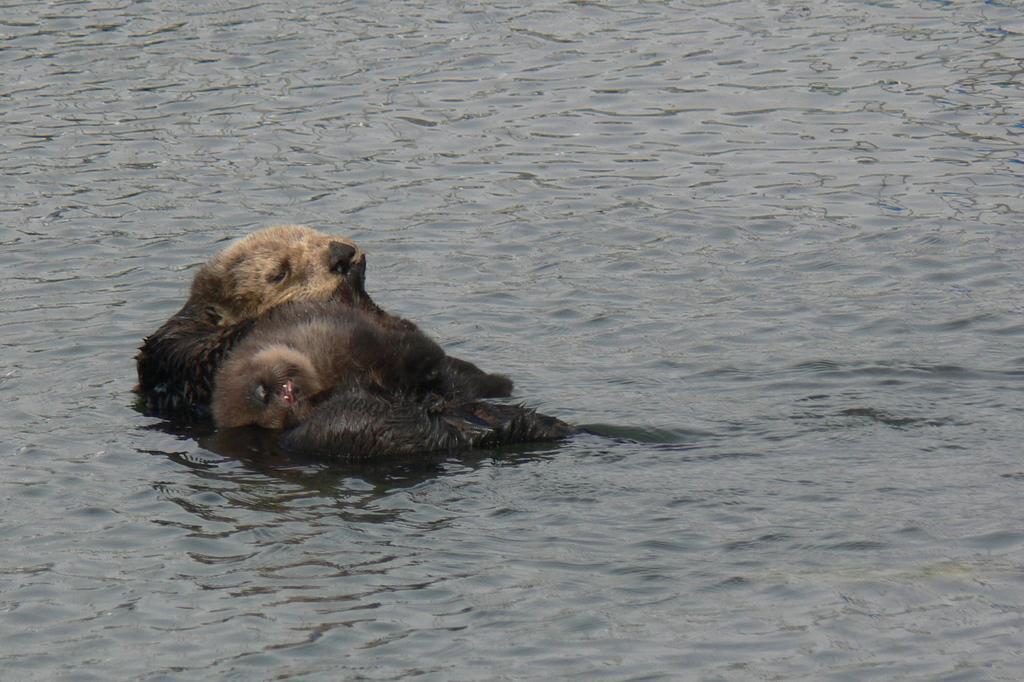What is the main subject of the image? There is an animal in the water in the image. Can you describe the animal's location in the image? The animal is in the water. What type of environment is depicted in the image? The image shows a water environment. How many eyes can be seen on the tin in the image? There is no tin present in the image, and therefore no eyes can be seen on it. 